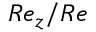Convert formula to latex. <formula><loc_0><loc_0><loc_500><loc_500>R e _ { z } / R e</formula> 